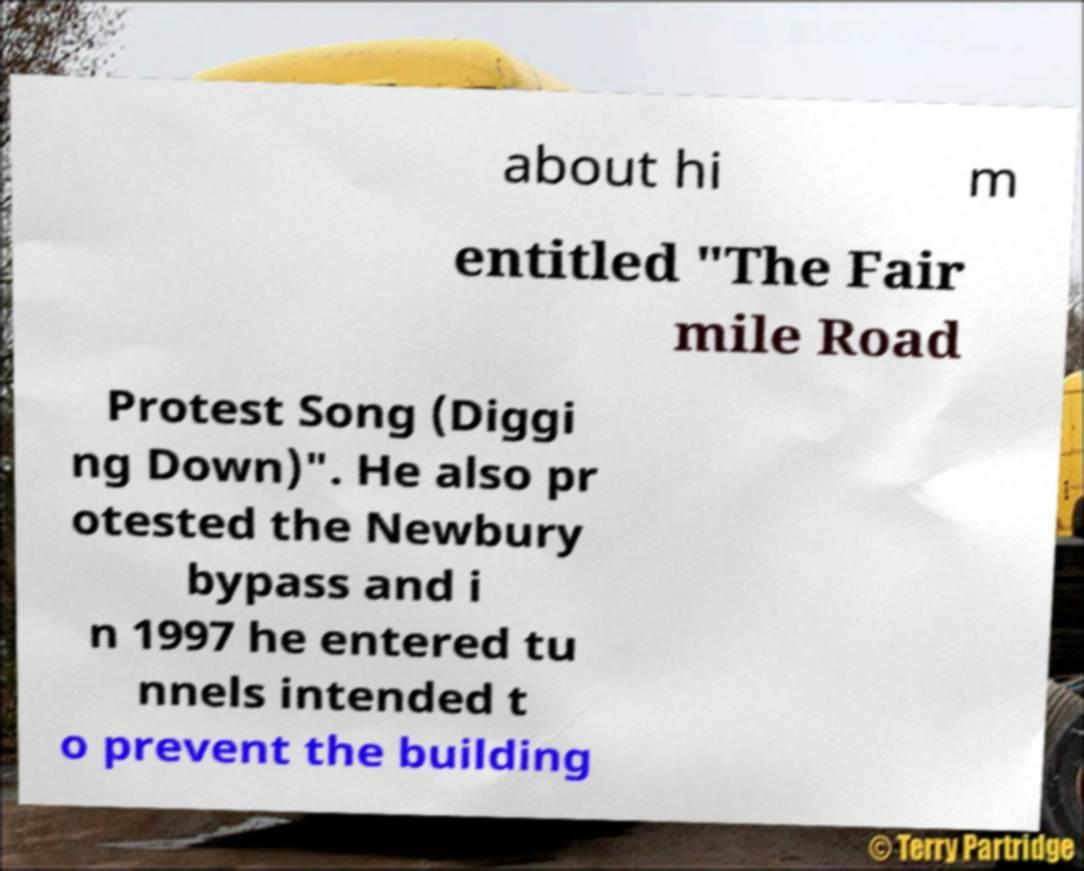Please identify and transcribe the text found in this image. about hi m entitled "The Fair mile Road Protest Song (Diggi ng Down)". He also pr otested the Newbury bypass and i n 1997 he entered tu nnels intended t o prevent the building 